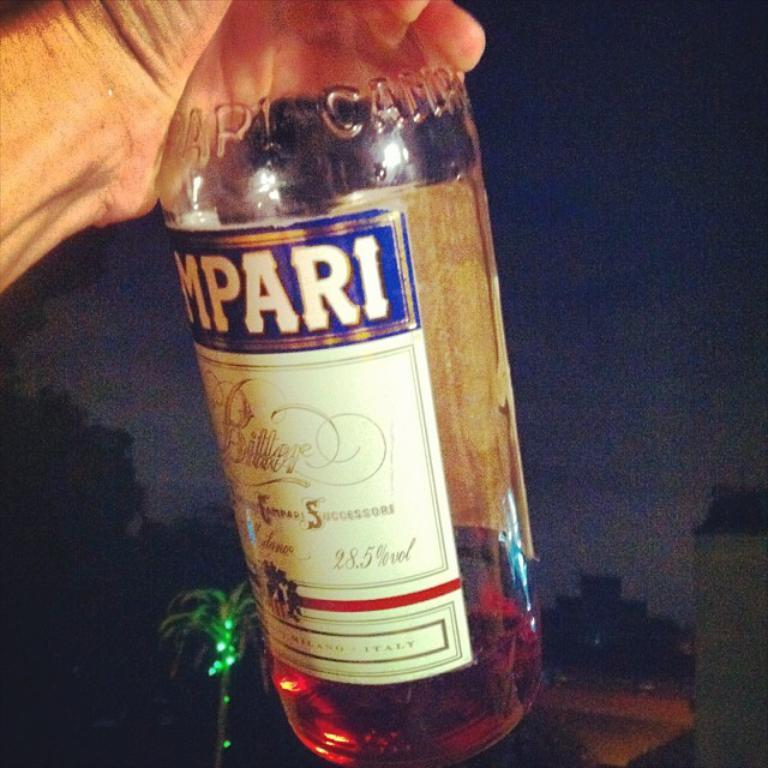What object is being held by a person in the image? There is a glass bottle in the image, and it is being held by a person. What type of furniture is being copied by the person holding the glass bottle in the image? There is no furniture present in the image, nor is there any indication that the person is copying anything. 